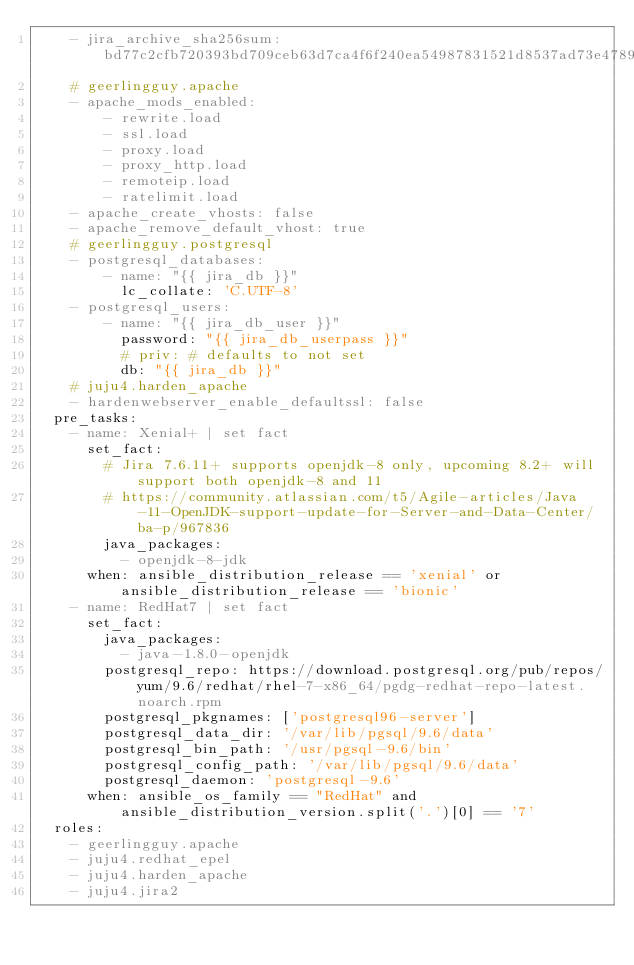Convert code to text. <code><loc_0><loc_0><loc_500><loc_500><_YAML_>    - jira_archive_sha256sum: bd77c2cfb720393bd709ceb63d7ca4f6f240ea54987831521d8537ad73e47896
    # geerlingguy.apache
    - apache_mods_enabled:
        - rewrite.load
        - ssl.load
        - proxy.load
        - proxy_http.load
        - remoteip.load
        - ratelimit.load
    - apache_create_vhosts: false
    - apache_remove_default_vhost: true
    # geerlingguy.postgresql
    - postgresql_databases:
        - name: "{{ jira_db }}"
          lc_collate: 'C.UTF-8'
    - postgresql_users:
        - name: "{{ jira_db_user }}"
          password: "{{ jira_db_userpass }}"
          # priv: # defaults to not set
          db: "{{ jira_db }}"
    # juju4.harden_apache
    - hardenwebserver_enable_defaultssl: false
  pre_tasks:
    - name: Xenial+ | set fact
      set_fact:
        # Jira 7.6.11+ supports openjdk-8 only, upcoming 8.2+ will support both openjdk-8 and 11
        # https://community.atlassian.com/t5/Agile-articles/Java-11-OpenJDK-support-update-for-Server-and-Data-Center/ba-p/967836
        java_packages:
          - openjdk-8-jdk
      when: ansible_distribution_release == 'xenial' or ansible_distribution_release == 'bionic'
    - name: RedHat7 | set fact
      set_fact:
        java_packages:
          - java-1.8.0-openjdk
        postgresql_repo: https://download.postgresql.org/pub/repos/yum/9.6/redhat/rhel-7-x86_64/pgdg-redhat-repo-latest.noarch.rpm
        postgresql_pkgnames: ['postgresql96-server']
        postgresql_data_dir: '/var/lib/pgsql/9.6/data'
        postgresql_bin_path: '/usr/pgsql-9.6/bin'
        postgresql_config_path: '/var/lib/pgsql/9.6/data'
        postgresql_daemon: 'postgresql-9.6'
      when: ansible_os_family == "RedHat" and ansible_distribution_version.split('.')[0] == '7'
  roles:
    - geerlingguy.apache
    - juju4.redhat_epel
    - juju4.harden_apache
    - juju4.jira2
</code> 